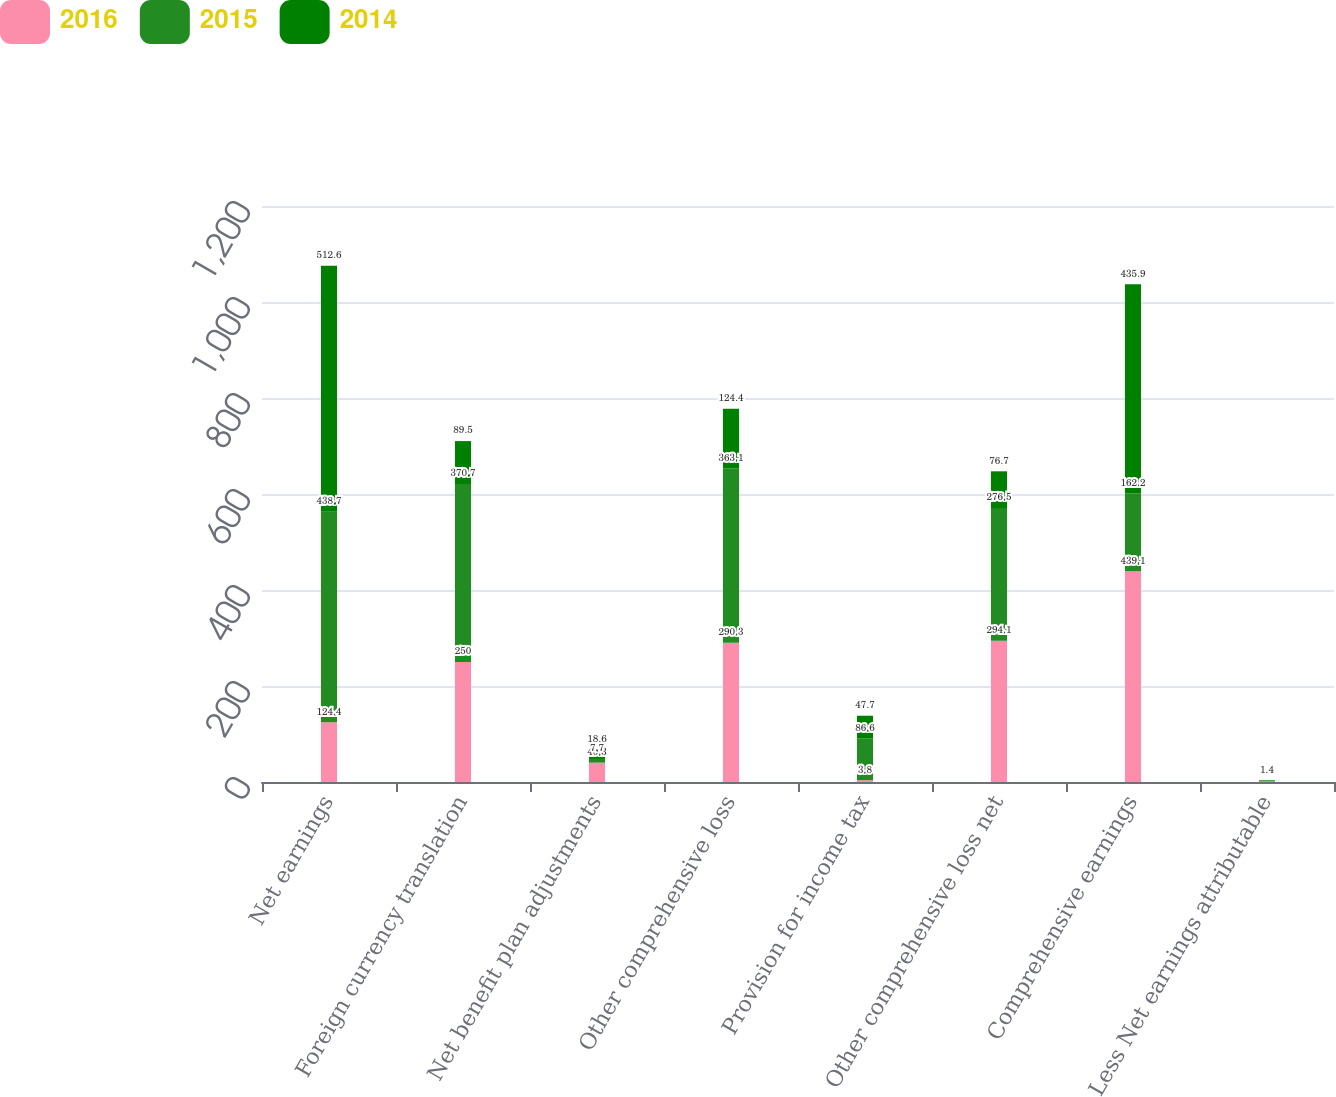<chart> <loc_0><loc_0><loc_500><loc_500><stacked_bar_chart><ecel><fcel>Net earnings<fcel>Foreign currency translation<fcel>Net benefit plan adjustments<fcel>Other comprehensive loss<fcel>Provision for income tax<fcel>Other comprehensive loss net<fcel>Comprehensive earnings<fcel>Less Net earnings attributable<nl><fcel>2016<fcel>124.4<fcel>250<fcel>40.3<fcel>290.3<fcel>3.8<fcel>294.1<fcel>439.1<fcel>1.1<nl><fcel>2015<fcel>438.7<fcel>370.7<fcel>7.7<fcel>363.1<fcel>86.6<fcel>276.5<fcel>162.2<fcel>1.1<nl><fcel>2014<fcel>512.6<fcel>89.5<fcel>18.6<fcel>124.4<fcel>47.7<fcel>76.7<fcel>435.9<fcel>1.4<nl></chart> 